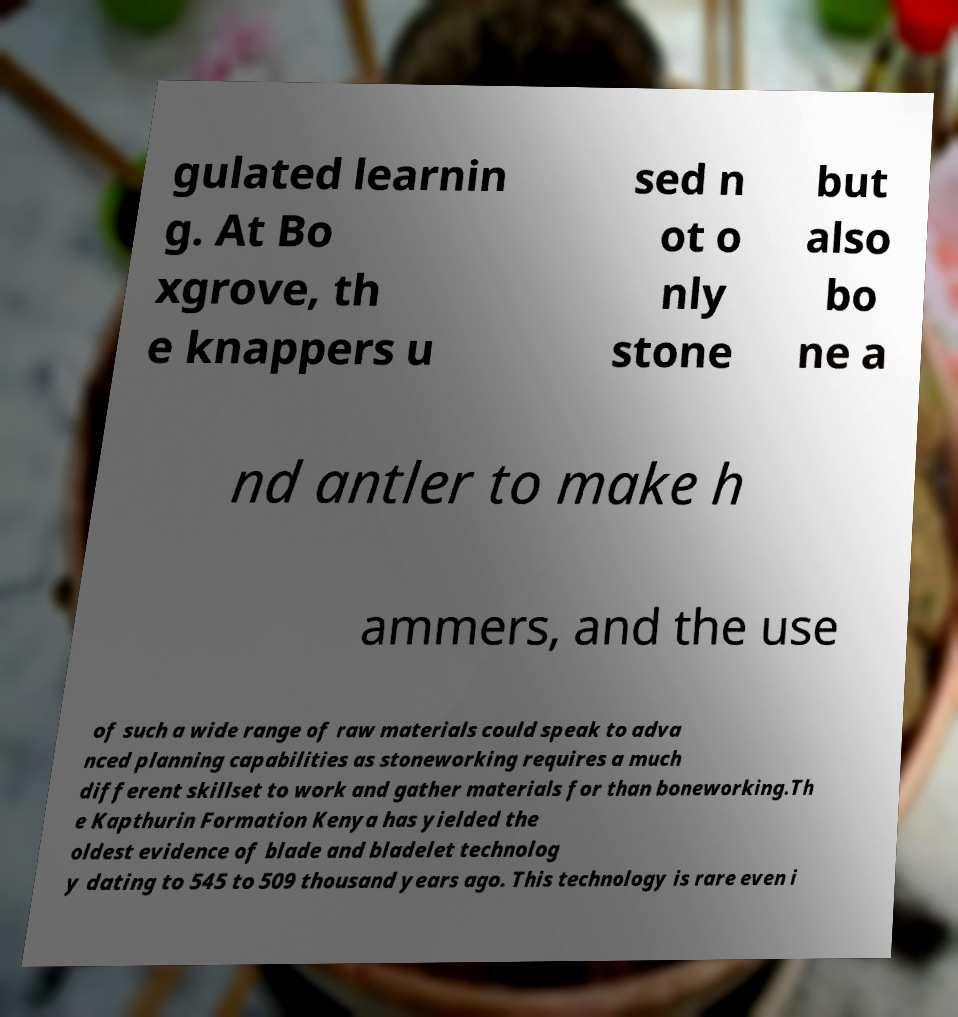What messages or text are displayed in this image? I need them in a readable, typed format. gulated learnin g. At Bo xgrove, th e knappers u sed n ot o nly stone but also bo ne a nd antler to make h ammers, and the use of such a wide range of raw materials could speak to adva nced planning capabilities as stoneworking requires a much different skillset to work and gather materials for than boneworking.Th e Kapthurin Formation Kenya has yielded the oldest evidence of blade and bladelet technolog y dating to 545 to 509 thousand years ago. This technology is rare even i 